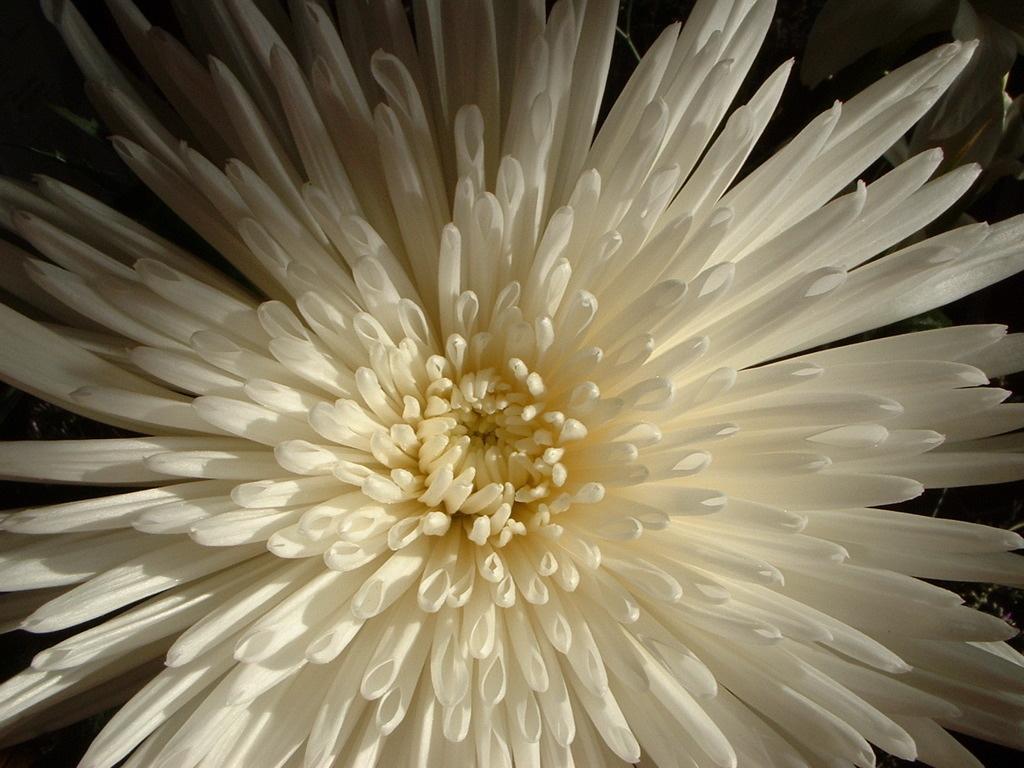Describe this image in one or two sentences. In this picture I can observe a flower. The flower is in white color. In the middle of the flower I can observe yellow color. The background is dark. 